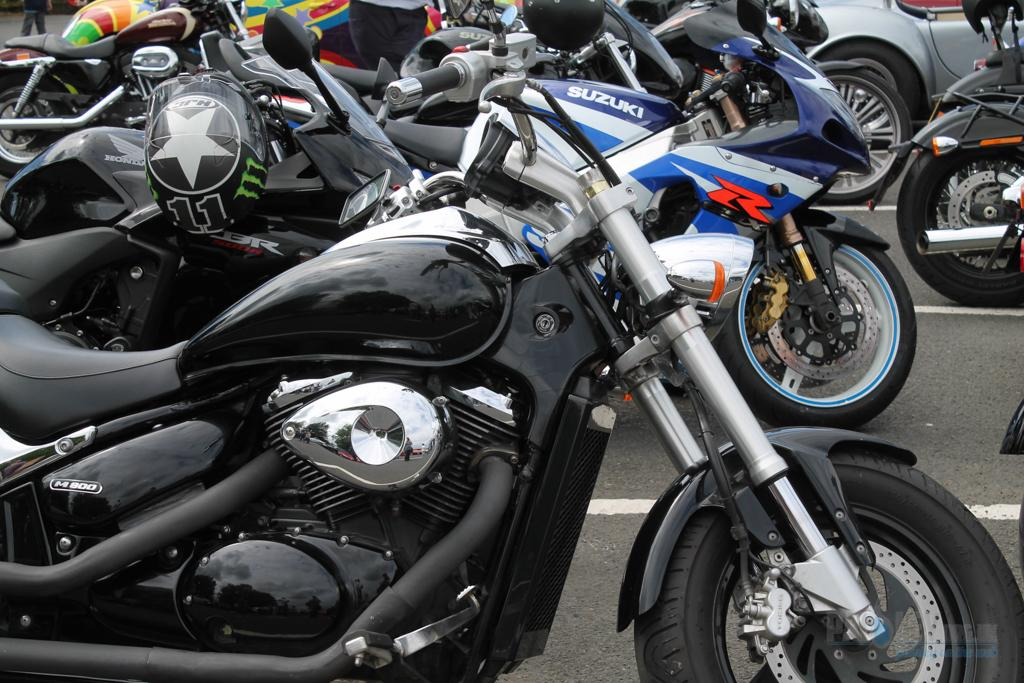What is the main subject of the picture? The main subject of the picture is a road. What can be seen on the road in the picture? There are multiple bikes on the road in the picture. Can you describe an object related to safety visible in the picture? Yes, there is a helmet visible on the left side of the picture. What type of rhythm can be heard coming from the trees in the picture? There are no trees present in the picture, so it's not possible to determine what rhythm might be heard. 